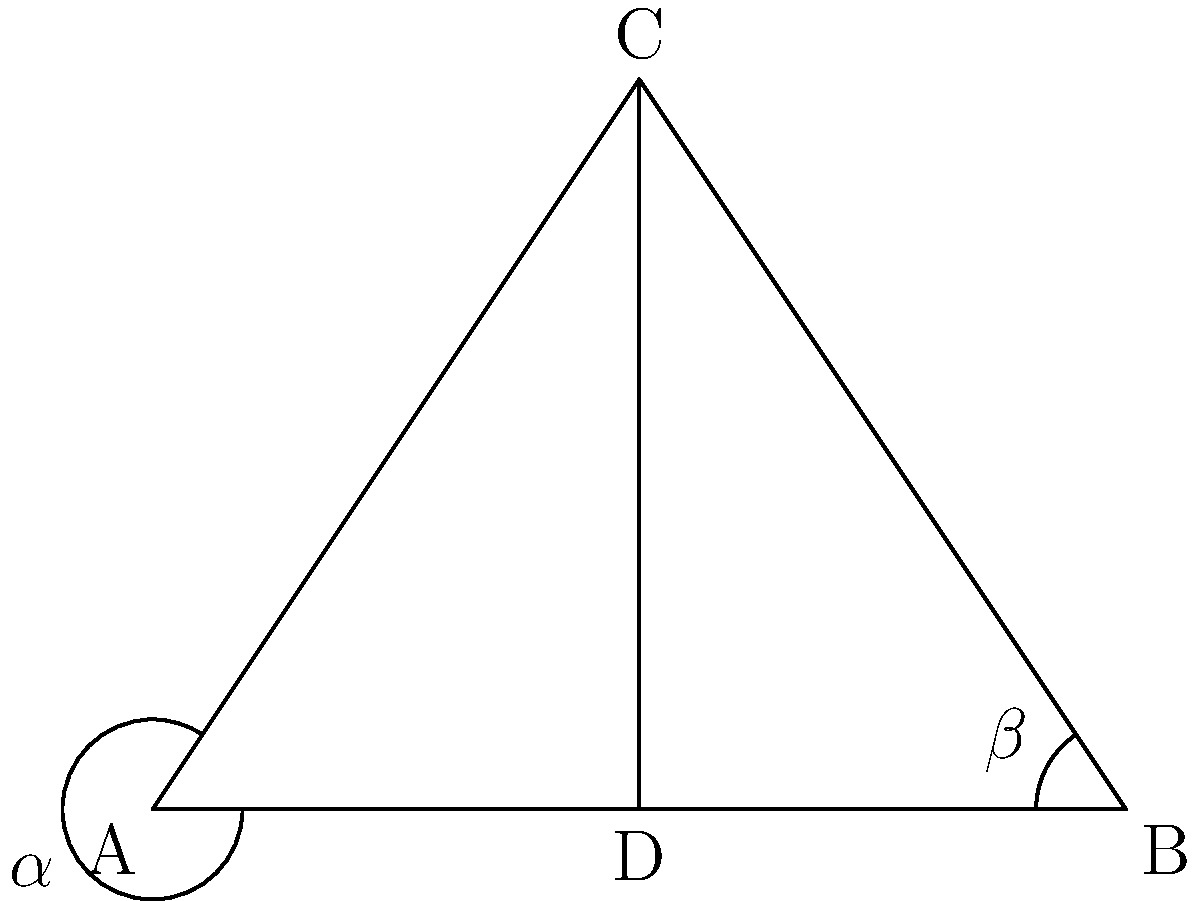In the design of a classic country guitar, the shape of the body often resembles a triangle. Consider the triangular shape ABC in the diagram, where CD is a line drawn from the vertex C to the midpoint D of side AB. If angle $\alpha = 35°$, what is the measure of angle $\beta$? To solve this problem, let's follow these steps:

1. Recognize that CD is a median of triangle ABC, as D is the midpoint of AB.

2. In any triangle, a median divides the triangle into two equal-area triangles.

3. When a median divides a triangle into two equal-area triangles, it also creates two congruent angles where it meets the base. This means that $\alpha = \beta$.

4. Since we're given that $\alpha = 35°$, we can conclude that $\beta$ must also be 35°.

5. We can verify this by noting that in any triangle, the sum of all angles is 180°. If $\alpha$ and $\beta$ are equal and the third angle (at vertex C) is bisected by CD, then $\alpha + \beta + (\text{angle at C}) = 180°$, or $35° + 35° + 110° = 180°$.

Therefore, angle $\beta$ measures 35°.
Answer: $35°$ 